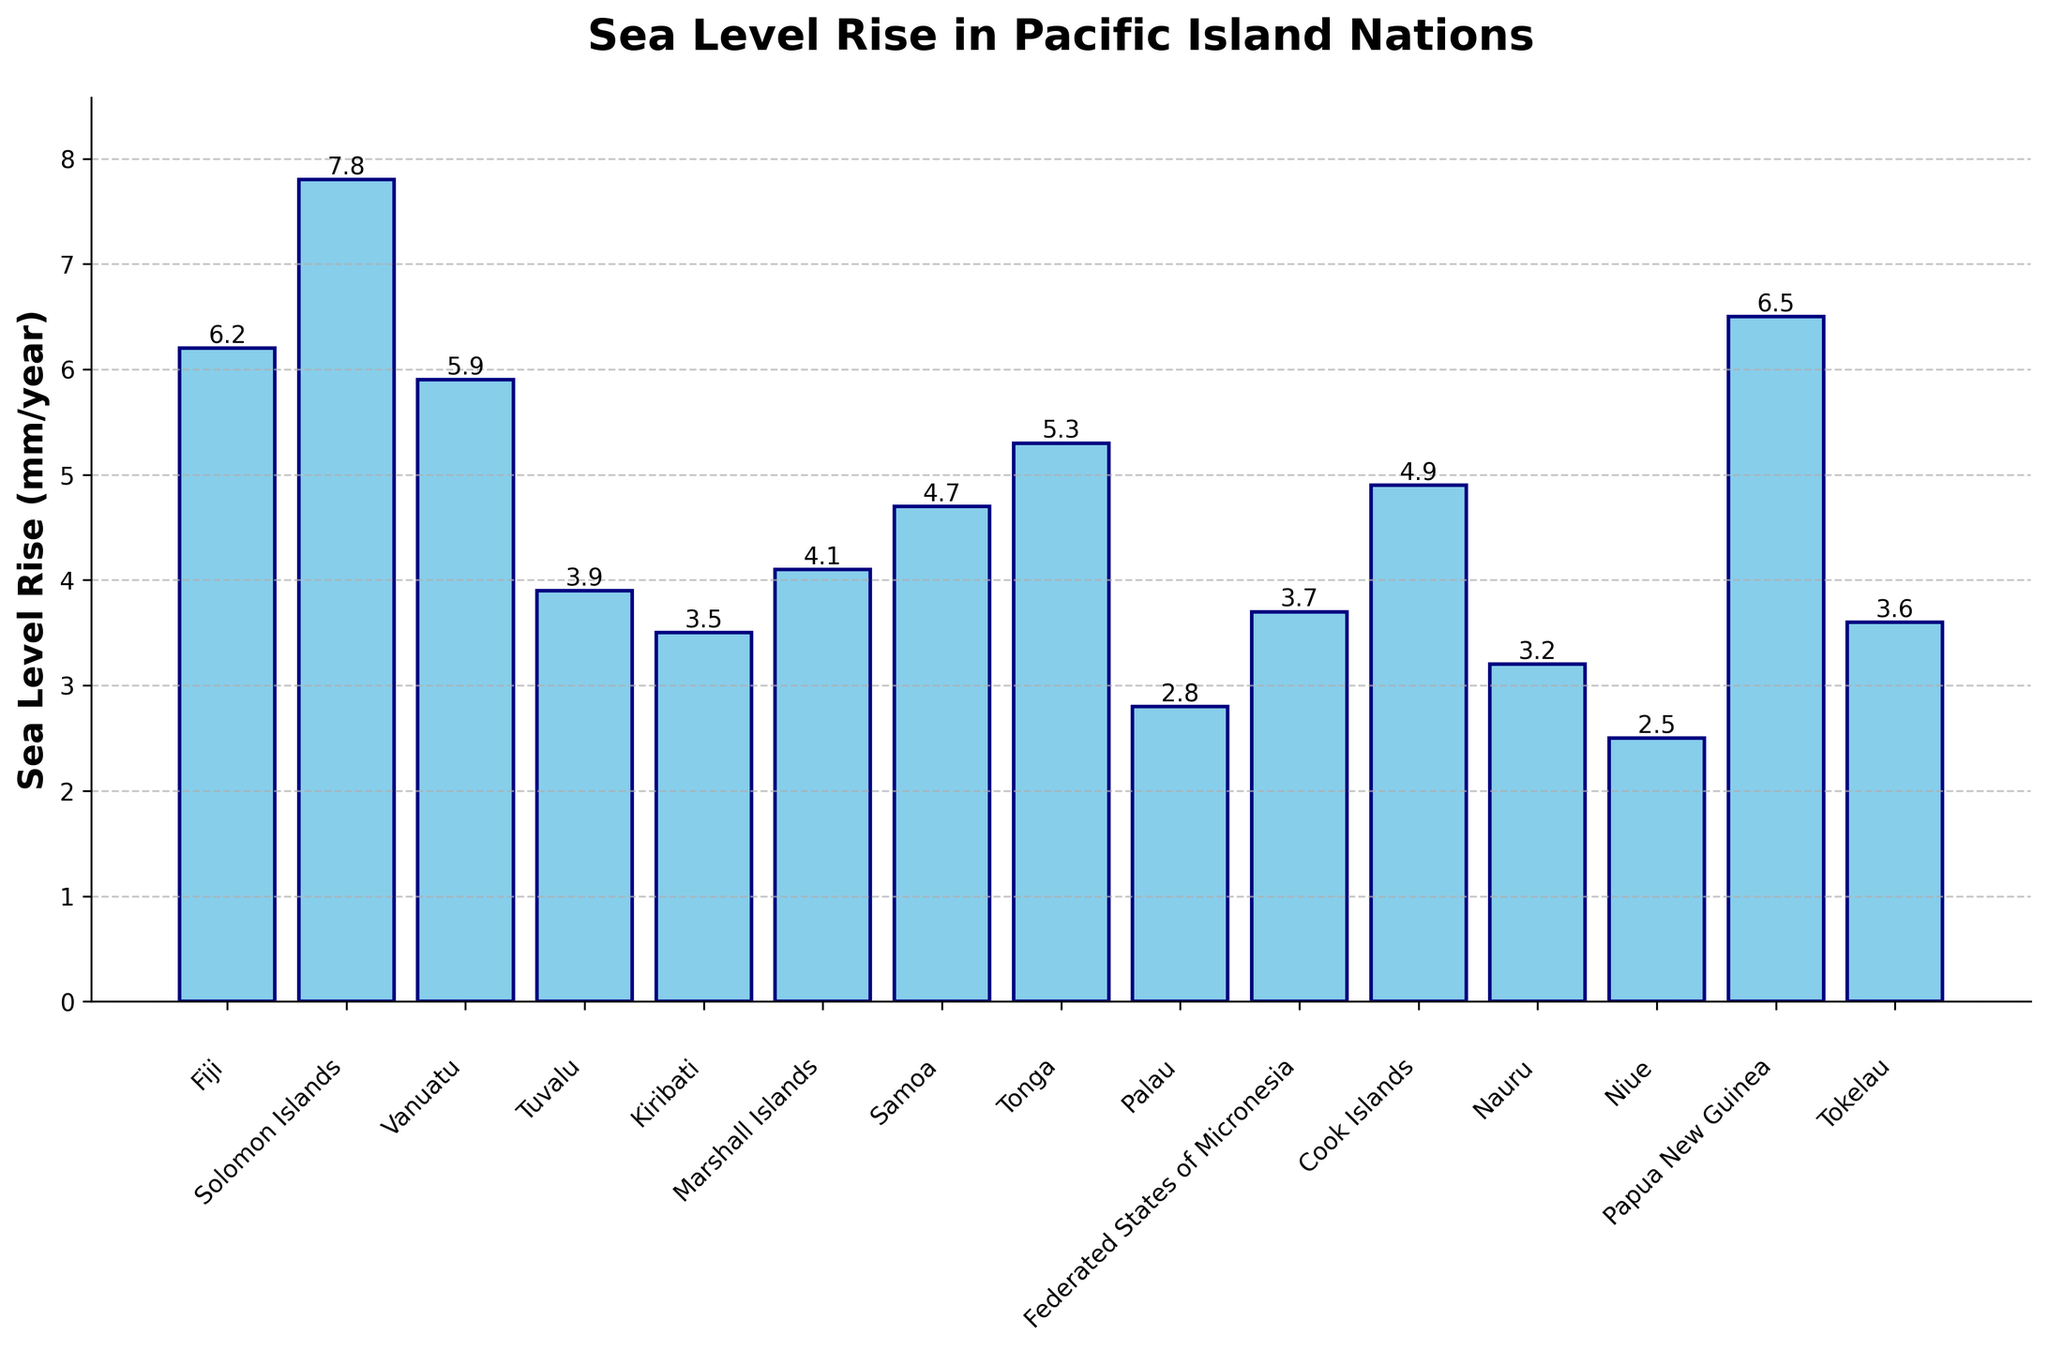What's the country with the highest sea level rise? Looking at the longest bar, it corresponds to the Solomon Islands, indicating it has the highest sea level rise.
Answer: Solomon Islands Which country experiences a lower sea level rise, Palau or Fiji? Compare the heights of the bars for Palau and Fiji. The bar for Palau is shorter than that for Fiji.
Answer: Palau What is the average sea level rise across all the countries? Sum all the sea level rise values: 6.2 + 7.8 + 5.9 + 3.9 + 3.5 + 4.1 + 4.7 + 5.3 + 2.8 + 3.7 + 4.9 + 3.2 + 2.5 + 6.5 + 3.6 = 68.6. There are 15 countries, so the average is 68.6 / 15.
Answer: 4.57 mm/year Which country has a sea level rise closest to the median value? List values in ascending order: 2.5, 2.8, 3.2, 3.5, 3.6, 3.7, 3.9, 4.1, 4.7, 4.9, 5.3, 5.9, 6.2, 6.5, 7.8. The median value is the 8th number: 4.1. The Marshall Islands has a rise of 4.1 mm/year.
Answer: Marshall Islands How much higher is the sea level rise in the Solomon Islands compared to Tokelau? The Solomon Islands' rise is 7.8 mm/year and Tokelau's is 3.6 mm/year, the difference is 7.8 - 3.6
Answer: 4.2 mm/year Which countries have a sea level rise higher than 5 mm/year? Identify bars taller than the 5 mm mark: Fiji (6.2), Solomon Islands (7.8), Vanuatu (5.9), Tonga (5.3), Papua New Guinea (6.5).
Answer: Fiji, Solomon Islands, Vanuatu, Tonga, Papua New Guinea What is the combined sea level rise for all the countries with more than 5 mm/year? Sum values greater than 5: 6.2 + 7.8 + 5.9 + 5.3 + 6.5 = 31.7
Answer: 31.7 mm/year Which country with a sea level rise below 3 mm/year has the lowest value? List countries under 3 mm/year and compare their values: Palau (2.8), Nauru (3.2), Niue (2.5). Niue has the lowest value at 2.5 mm/year.
Answer: Niue How many countries have a sea level rise between 3 and 5 mm/year? Count the bars that fall in the 3-5 mm range: Tuvalu (3.9), Kiribati (3.5), Marshall Islands (4.1), Samoa (4.7), Federated States of Micronesia (3.7), Cook Islands (4.9), Tokelau (3.6).
Answer: 7 